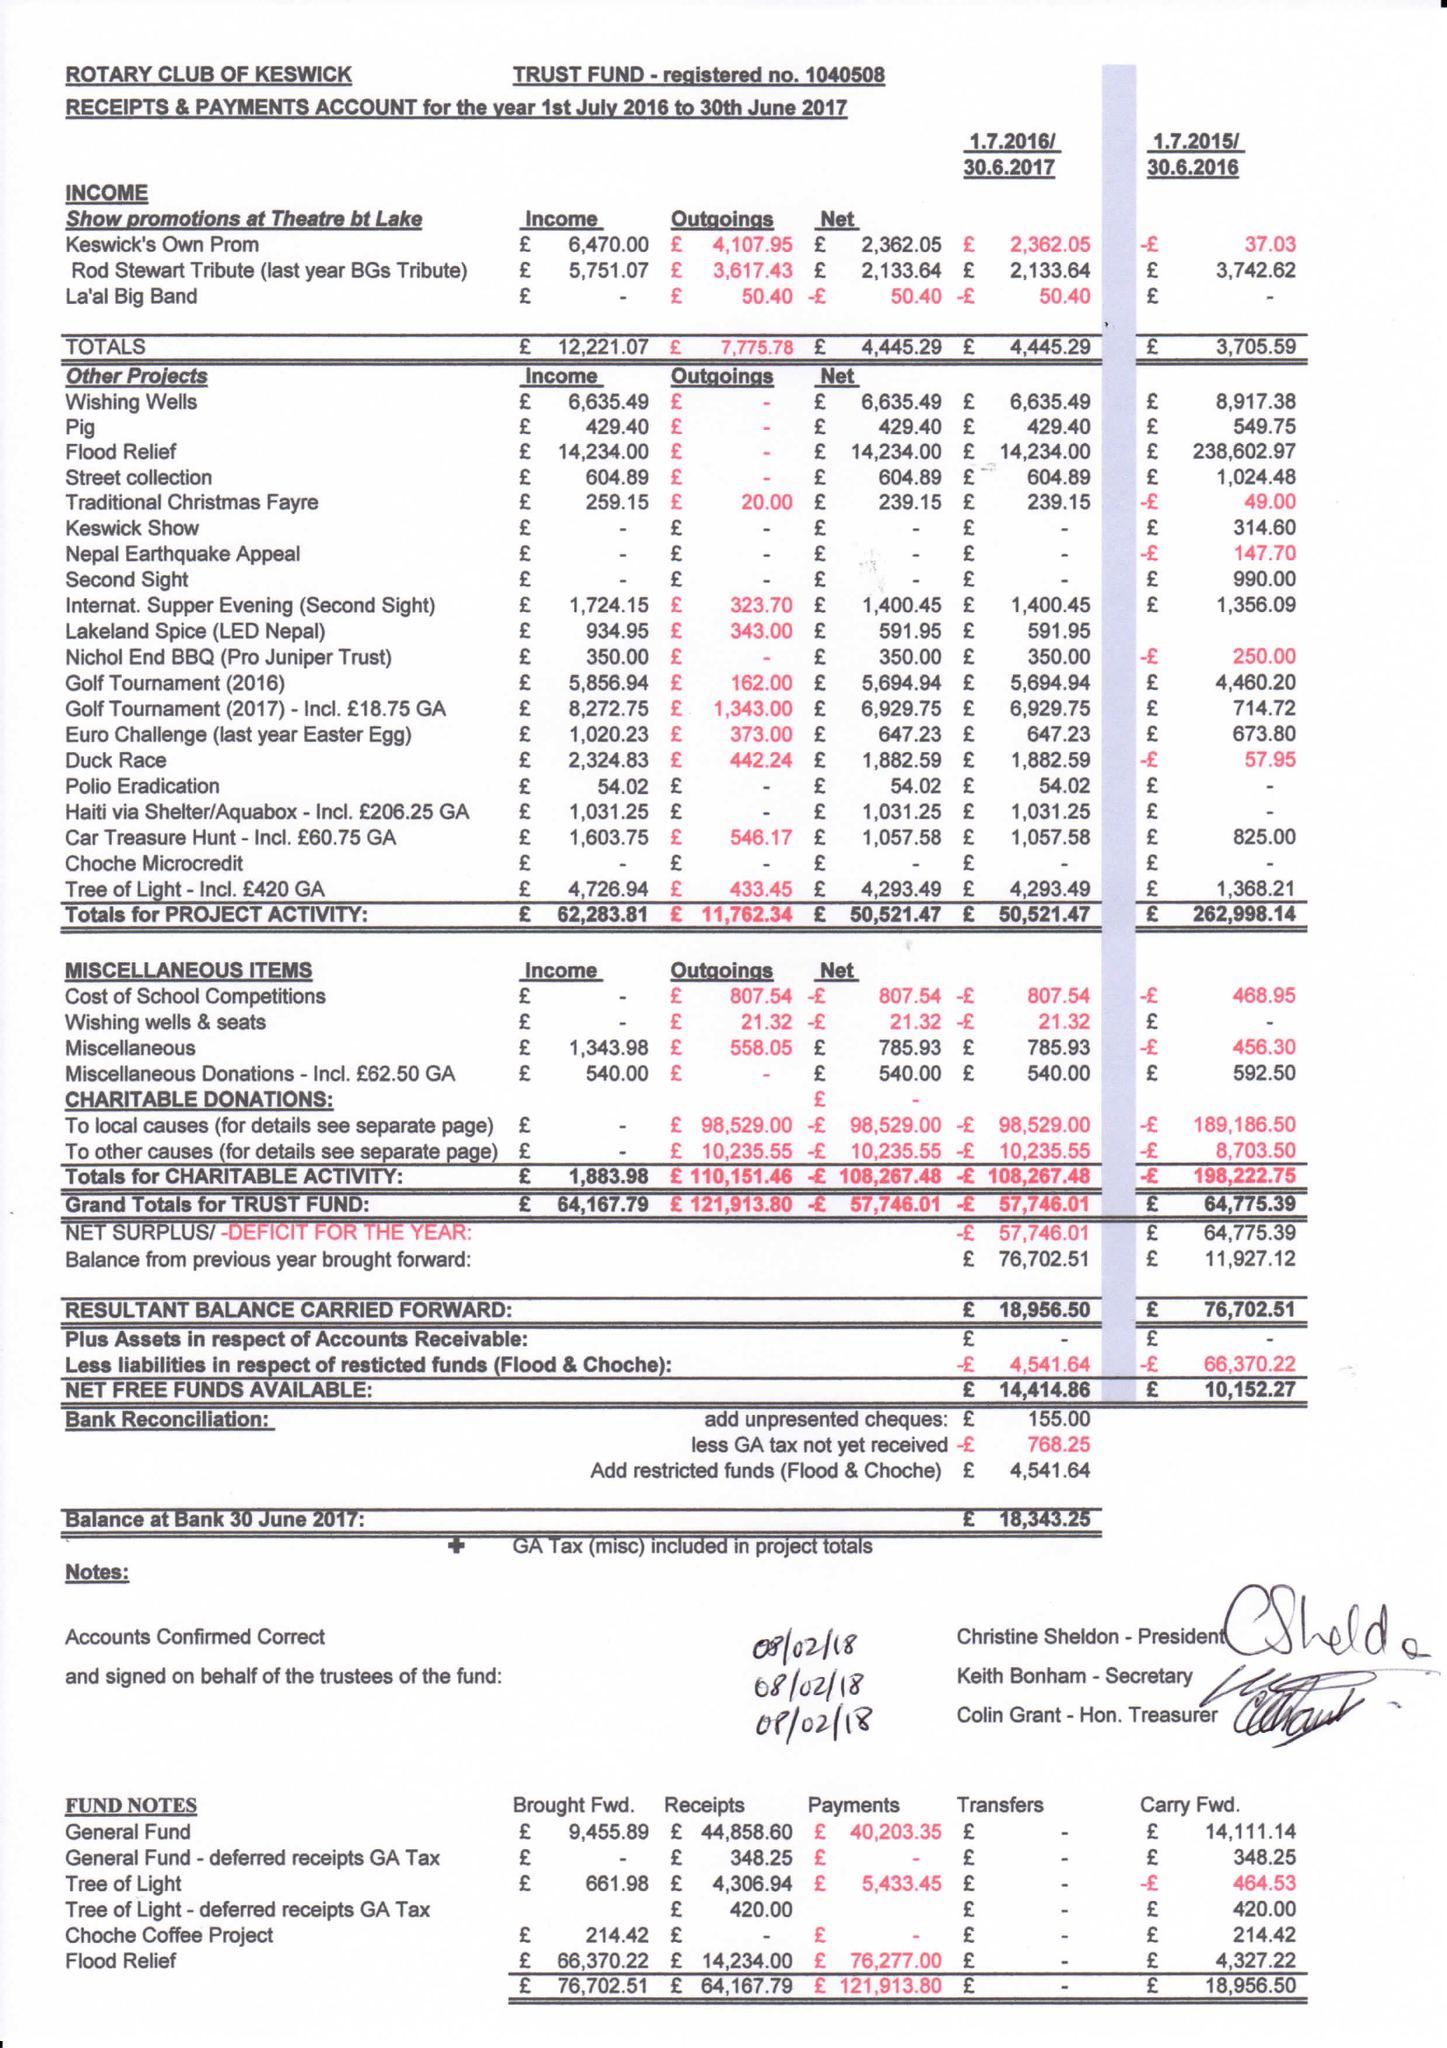What is the value for the address__post_town?
Answer the question using a single word or phrase. CARLISLE 